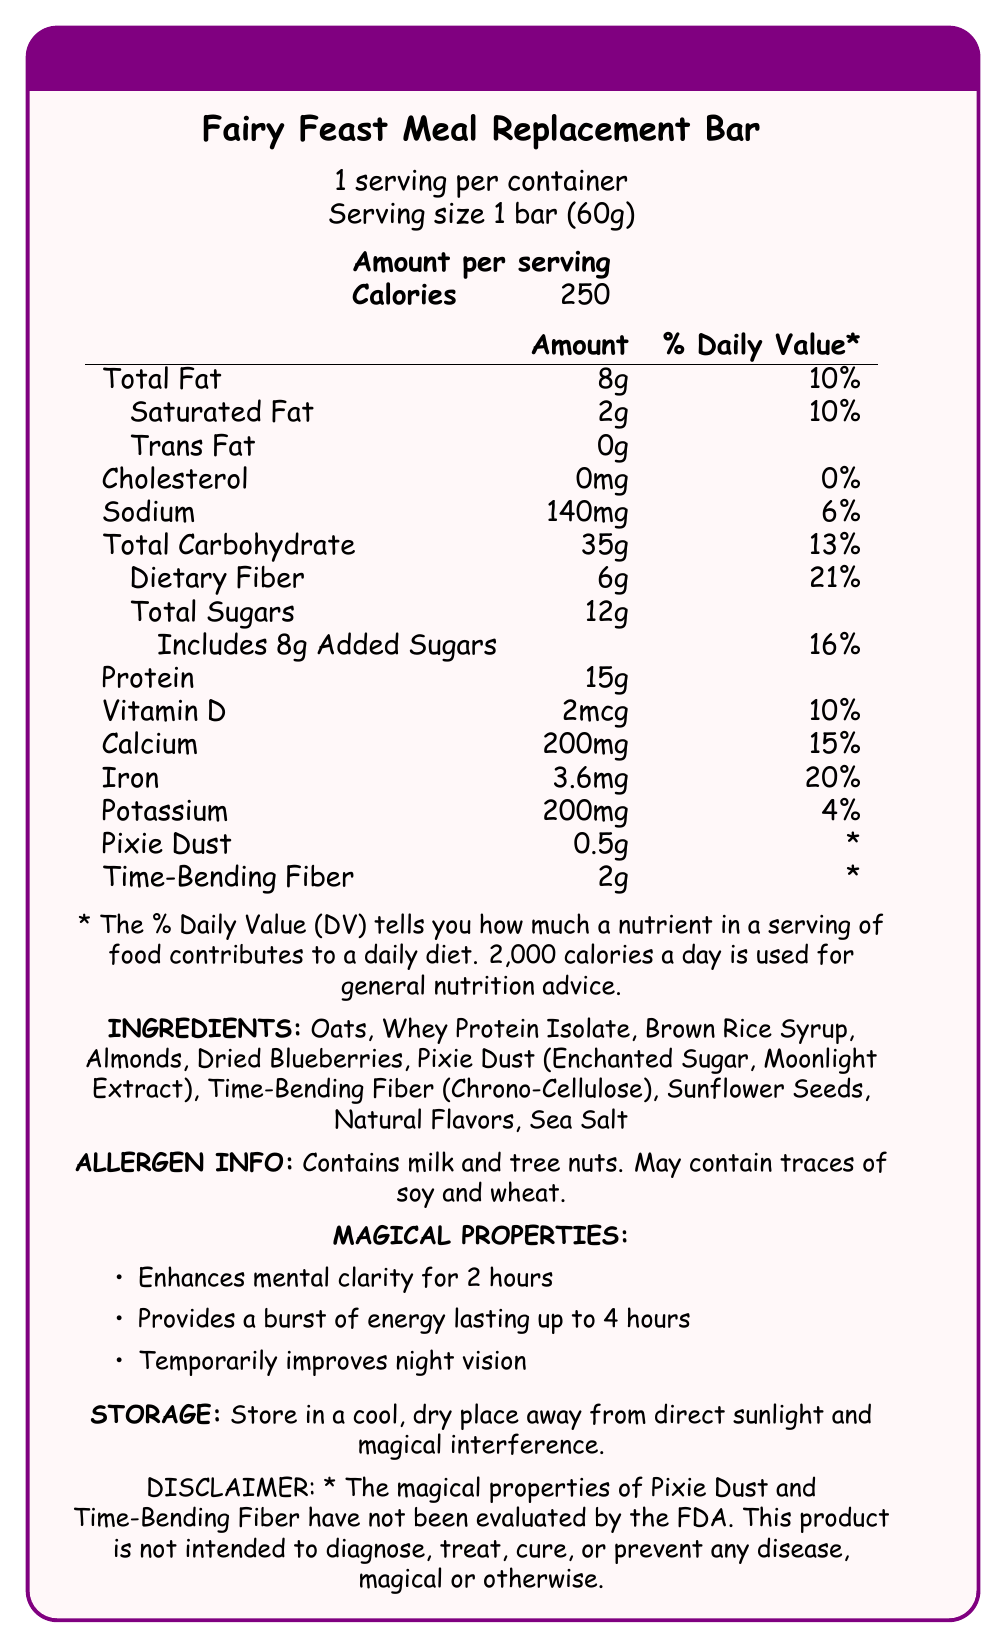what is the serving size of the Fairy Feast Meal Replacement Bar? The serving size is specifically mentioned as "1 bar (60g)" in the document.
Answer: 1 bar (60g) how many calories are in one serving of the Fairy Feast Meal Replacement Bar? The document states the calorie count per serving as 250.
Answer: 250 how much protein does each bar contain? The protein content is listed in the nutrition facts section as 15g per bar.
Answer: 15g which allergens are mentioned in the Fairy Feast Meal Replacement Bar? The allergen information clearly states that the bar contains milk and tree nuts.
Answer: milk and tree nuts what are the magical properties of the Fairy Feast Meal Replacement Bar? These magical properties are listed under the magical properties section.
Answer: Enhances mental clarity for 2 hours, Provides a burst of energy lasting up to 4 hours, Temporarily improves night vision how much dietary fiber does the Fairy Feast Meal Replacement Bar have, and what percentage of the daily value does it represent? The dietary fiber content is 6g, and it represents 21% of the daily value.
Answer: 6g, 21% what ingredients are used to make the Fairy Feast Meal Replacement Bar? A. Oats, Whey Protein Isolate, Brown Rice Syrup, Almonds B. Dried Blueberries, Pixie Dust, Sea Salt C. Sunflower Seeds, Natural Flavors, Sea Salt D. All of the above The ingredients list includes all the options mentioned.
Answer: D. All of the above how should the Fairy Feast Meal Replacement Bar be stored? A. In a damp place B. In sunlight C. In a cool, dry place away from direct sunlight and magical interference D. In a freezer The correct storage method is listed in the storage instructions.
Answer: C. In a cool, dry place away from direct sunlight and magical interference are the magical properties of the Fairy Feast Meal Replacement Bar evaluated by the FDA? The disclaimer specifies that the magical properties have not been evaluated by the FDA.
Answer: No how many servings are there per container? The document mentions that there are 6 servings per container.
Answer: 6 how much pixie dust is in the Fairy Feast Meal Replacement Bar? The amount of pixie dust is listed as 0.5g.
Answer: 0.5g does the Fairy Feast Meal Replacement Bar contain any cholesterol? The cholesterol content is listed as 0mg, indicating it does not contain any cholesterol.
Answer: No which of the following is not listed as an ingredient in the Fairy Feast Meal Replacement Bar? A. Soy B. Oats C. Almonds D. Whey Protein Isolate Soy is not listed as an ingredient in the bar.
Answer: A. Soy what is the main idea of the Fairy Feast Meal Replacement Bar's nutrition facts document? The document comprehensively details the nutritional content, ingredients, allergens, magical properties, and storage guidelines for the meal replacement bar.
Answer: The document provides detailed nutritional information, ingredients, allergen info, magical properties, and storage instructions for the Fairy Feast Meal Replacement Bar, emphasizing its unique components like pixie dust and time-bending fiber. how much time-bending fiber does the Fairy Feast Meal Replacement Bar contain? The document lists the time-bending fiber content as 2g.
Answer: 2g what is the daily value percentage for calcium in the Fairy Feast Meal Replacement Bar? The daily value percentage for calcium is listed as 15%.
Answer: 15% what is the total fat content and its daily value percentage in the Fairy Feast Meal Replacement Bar? The total fat content is 8g, which corresponds to 10% of the daily value.
Answer: 8g, 10% how much vitamin D is in the Fairy Feast Meal Replacement Bar? The vitamin D content is listed as 2mcg.
Answer: 2mcg what is the amount of total sugars in the Fairy Feast Meal Replacement Bar? The total sugars content is documented as 12g.
Answer: 12g how does the Fairy Feast Meal Replacement Bar potentially improve your vision? One of the magical properties listed is that it temporarily improves night vision.
Answer: Temporarily improves night vision can the exact source of pixie dust and time-bending fiber be determined from the document? The document mentions pixie dust and time-bending fiber but does not provide specifics about their exact sources.
Answer: Cannot be determined 